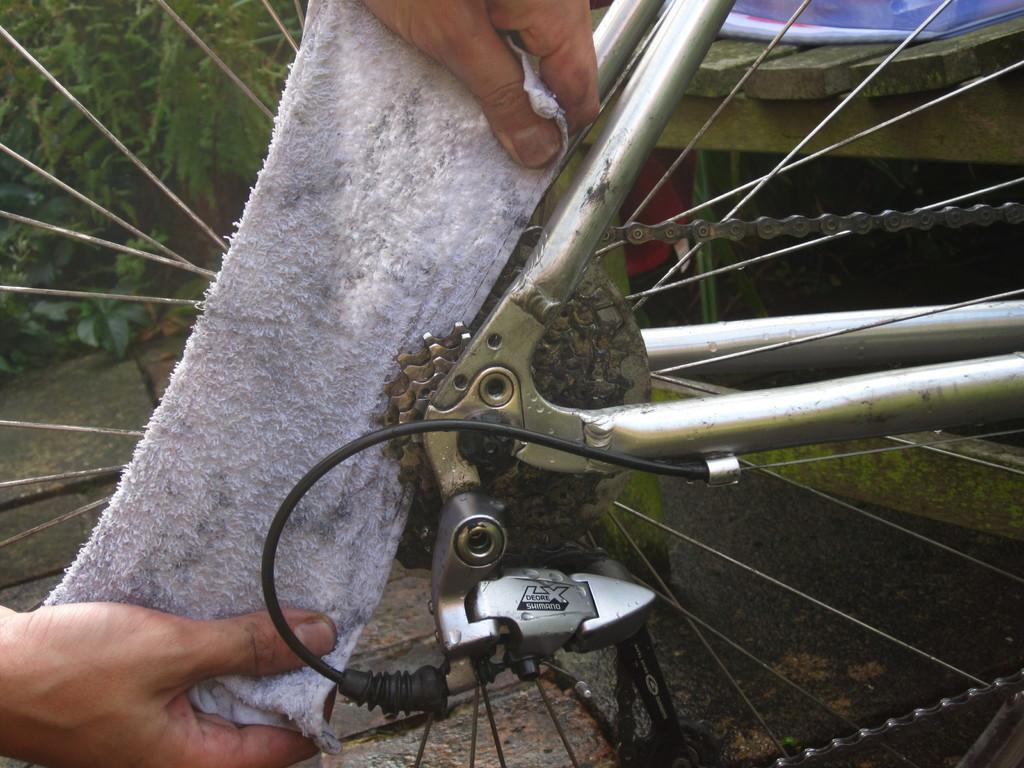Please provide a concise description of this image. In the center of the image we can see cycle wheel, chain and napkin. In the background we can see trees and bench. 